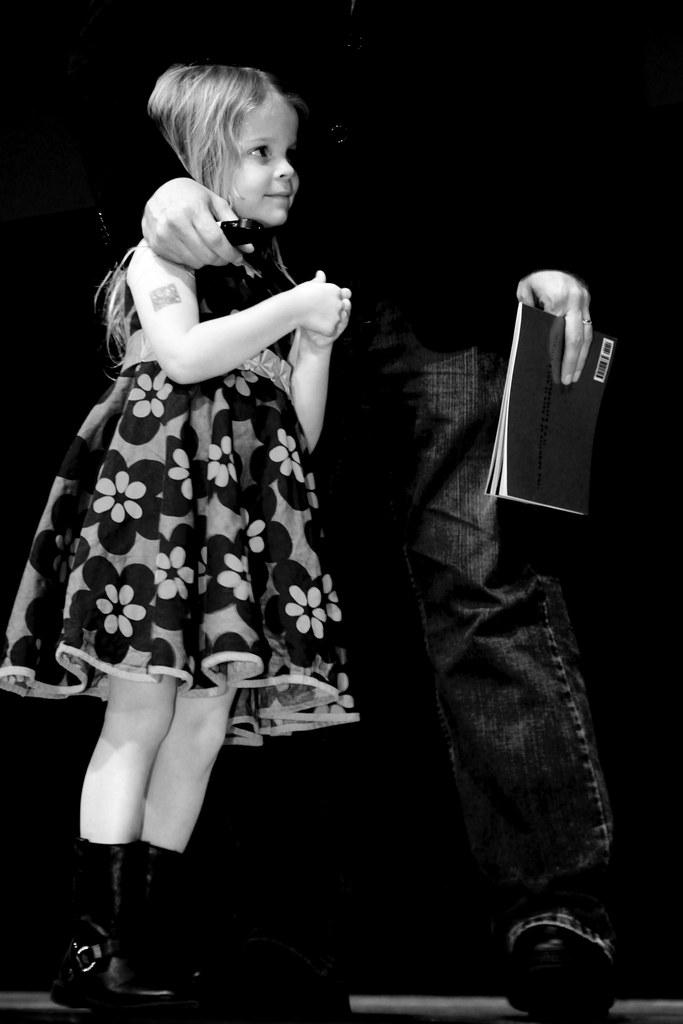What is the color scheme of the image? The image is black and white. Who is present in the image? There is a girl and a person holding a book in the image. Can you describe the person holding the book? The person holding the book is partially cut off or "truncated" in the image. What is the overall lighting or brightness of the image? The background of the image is dark. What type of wealth is depicted in the image? There is no depiction of wealth in the image; it features a girl and a person holding a book in a black and white setting. What type of sofa can be seen in the image? There is no sofa present in the image. 